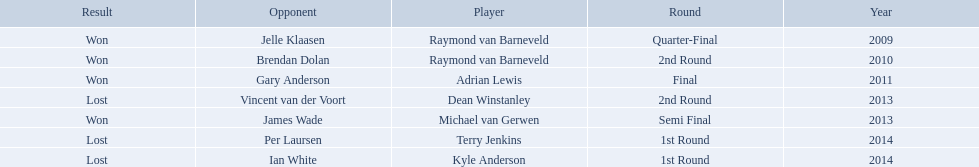Who are the players at the pdc world darts championship? Raymond van Barneveld, Raymond van Barneveld, Adrian Lewis, Dean Winstanley, Michael van Gerwen, Terry Jenkins, Kyle Anderson. When did kyle anderson lose? 2014. Which other players lost in 2014? Terry Jenkins. 